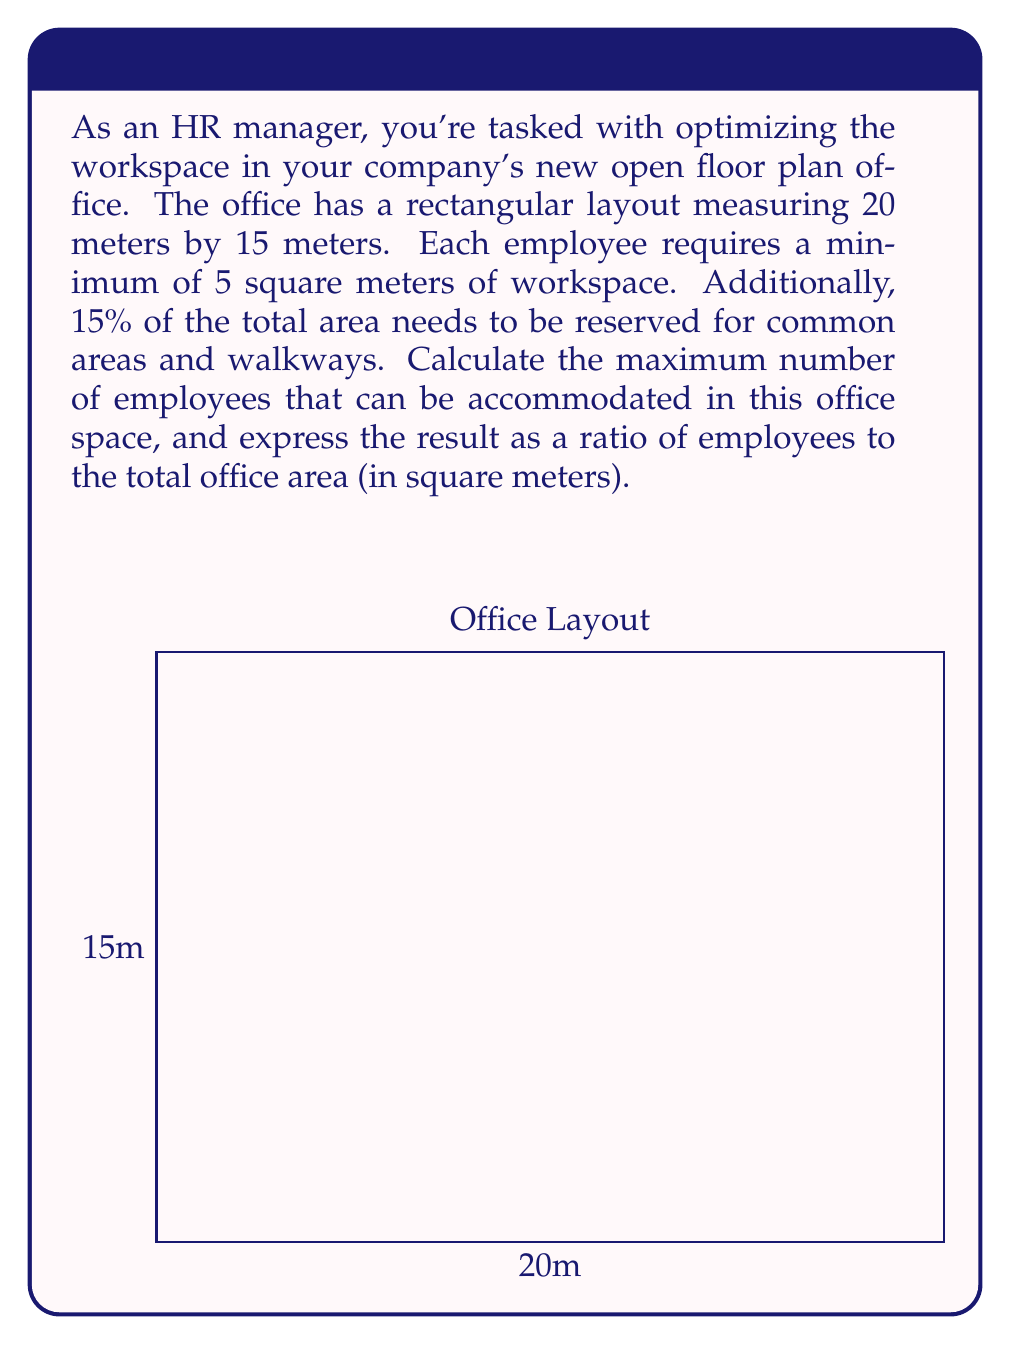Provide a solution to this math problem. Let's approach this problem step-by-step:

1. Calculate the total office area:
   $$\text{Total Area} = 20\text{ m} \times 15\text{ m} = 300\text{ m}^2$$

2. Calculate the area reserved for common spaces (15% of total):
   $$\text{Common Area} = 15\% \times 300\text{ m}^2 = 0.15 \times 300\text{ m}^2 = 45\text{ m}^2$$

3. Calculate the remaining area for workspaces:
   $$\text{Workspace Area} = 300\text{ m}^2 - 45\text{ m}^2 = 255\text{ m}^2$$

4. Calculate the maximum number of employees:
   $$\text{Max Employees} = \frac{\text{Workspace Area}}{\text{Area per Employee}} = \frac{255\text{ m}^2}{5\text{ m}^2} = 51$$

5. Express the ratio of employees to total office area:
   $$\text{Ratio} = \frac{51\text{ employees}}{300\text{ m}^2} = \frac{17\text{ employees}}{100\text{ m}^2}$$

This ratio can be simplified to 17:100.
Answer: 17:100 